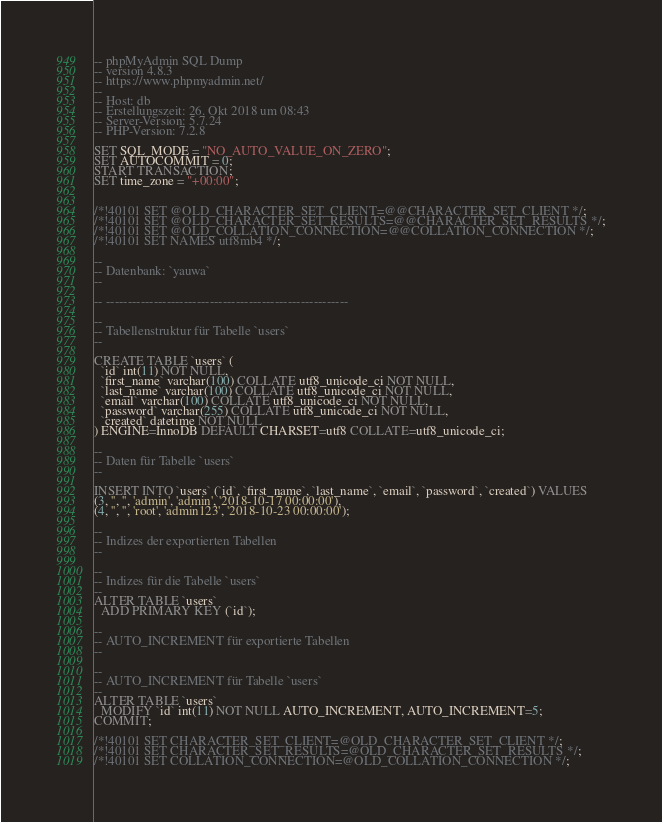<code> <loc_0><loc_0><loc_500><loc_500><_SQL_>-- phpMyAdmin SQL Dump
-- version 4.8.3
-- https://www.phpmyadmin.net/
--
-- Host: db
-- Erstellungszeit: 26. Okt 2018 um 08:43
-- Server-Version: 5.7.24
-- PHP-Version: 7.2.8

SET SQL_MODE = "NO_AUTO_VALUE_ON_ZERO";
SET AUTOCOMMIT = 0;
START TRANSACTION;
SET time_zone = "+00:00";


/*!40101 SET @OLD_CHARACTER_SET_CLIENT=@@CHARACTER_SET_CLIENT */;
/*!40101 SET @OLD_CHARACTER_SET_RESULTS=@@CHARACTER_SET_RESULTS */;
/*!40101 SET @OLD_COLLATION_CONNECTION=@@COLLATION_CONNECTION */;
/*!40101 SET NAMES utf8mb4 */;

--
-- Datenbank: `yauwa`
--

-- --------------------------------------------------------

--
-- Tabellenstruktur für Tabelle `users`
--

CREATE TABLE `users` (
  `id` int(11) NOT NULL,
  `first_name` varchar(100) COLLATE utf8_unicode_ci NOT NULL,
  `last_name` varchar(100) COLLATE utf8_unicode_ci NOT NULL,
  `email` varchar(100) COLLATE utf8_unicode_ci NOT NULL,
  `password` varchar(255) COLLATE utf8_unicode_ci NOT NULL,
  `created` datetime NOT NULL
) ENGINE=InnoDB DEFAULT CHARSET=utf8 COLLATE=utf8_unicode_ci;

--
-- Daten für Tabelle `users`
--

INSERT INTO `users` (`id`, `first_name`, `last_name`, `email`, `password`, `created`) VALUES
(3, '', '', 'admin', 'admin', '2018-10-17 00:00:00'),
(4, '', '', 'root', 'admin123', '2018-10-23 00:00:00');

--
-- Indizes der exportierten Tabellen
--

--
-- Indizes für die Tabelle `users`
--
ALTER TABLE `users`
  ADD PRIMARY KEY (`id`);

--
-- AUTO_INCREMENT für exportierte Tabellen
--

--
-- AUTO_INCREMENT für Tabelle `users`
--
ALTER TABLE `users`
  MODIFY `id` int(11) NOT NULL AUTO_INCREMENT, AUTO_INCREMENT=5;
COMMIT;

/*!40101 SET CHARACTER_SET_CLIENT=@OLD_CHARACTER_SET_CLIENT */;
/*!40101 SET CHARACTER_SET_RESULTS=@OLD_CHARACTER_SET_RESULTS */;
/*!40101 SET COLLATION_CONNECTION=@OLD_COLLATION_CONNECTION */;
</code> 